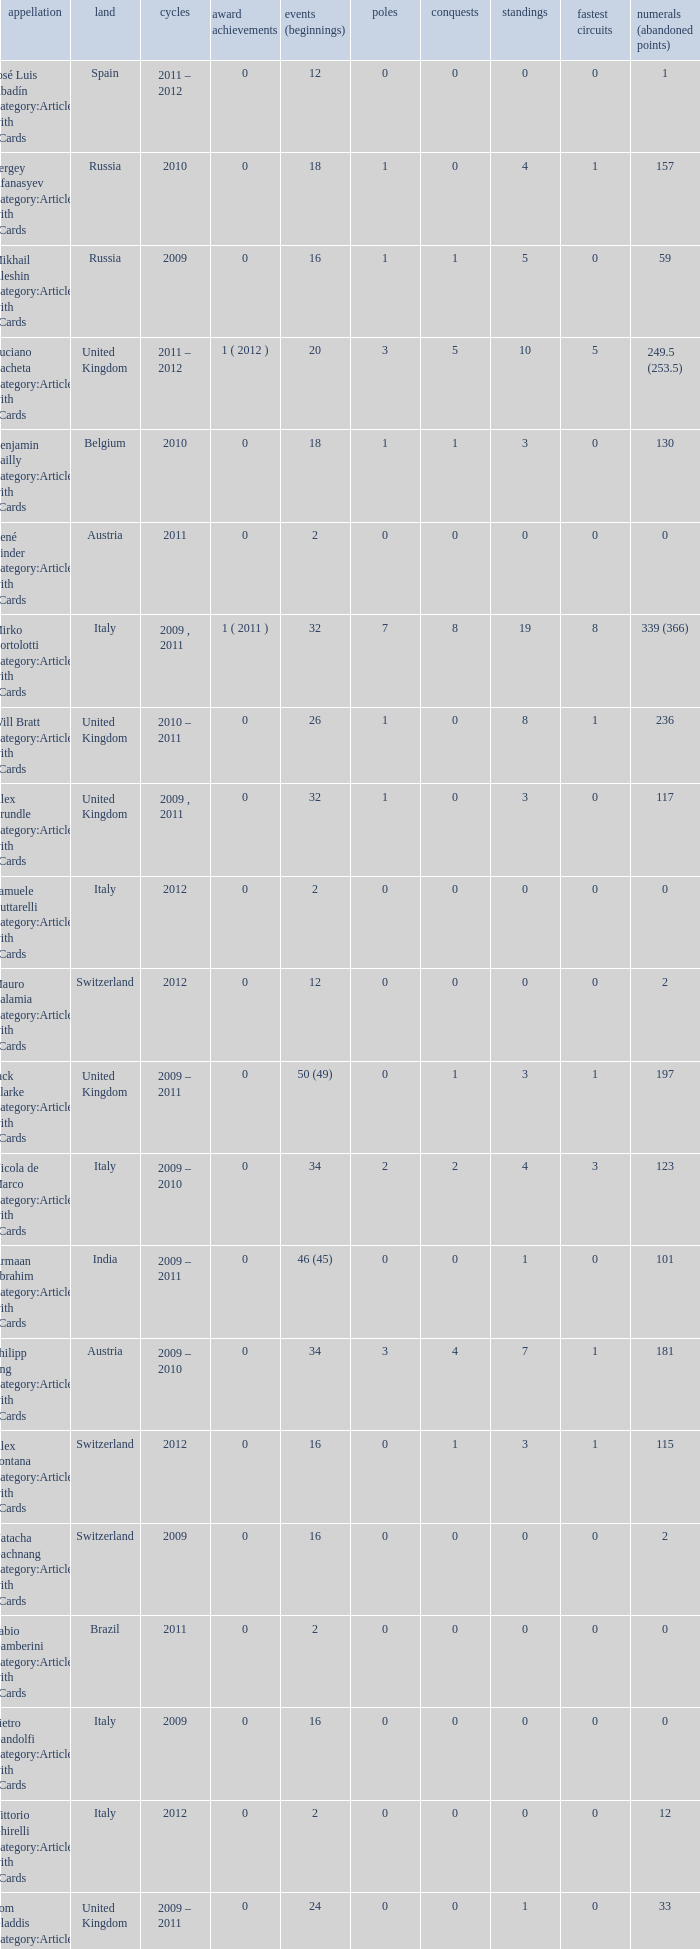What was the least amount of wins? 0.0. Could you parse the entire table as a dict? {'header': ['appellation', 'land', 'cycles', 'award achievements', 'events (beginnings)', 'poles', 'conquests', 'standings', 'fastest circuits', 'numerals (abandoned points)'], 'rows': [['José Luis Abadín Category:Articles with hCards', 'Spain', '2011 – 2012', '0', '12', '0', '0', '0', '0', '1'], ['Sergey Afanasyev Category:Articles with hCards', 'Russia', '2010', '0', '18', '1', '0', '4', '1', '157'], ['Mikhail Aleshin Category:Articles with hCards', 'Russia', '2009', '0', '16', '1', '1', '5', '0', '59'], ['Luciano Bacheta Category:Articles with hCards', 'United Kingdom', '2011 – 2012', '1 ( 2012 )', '20', '3', '5', '10', '5', '249.5 (253.5)'], ['Benjamin Bailly Category:Articles with hCards', 'Belgium', '2010', '0', '18', '1', '1', '3', '0', '130'], ['René Binder Category:Articles with hCards', 'Austria', '2011', '0', '2', '0', '0', '0', '0', '0'], ['Mirko Bortolotti Category:Articles with hCards', 'Italy', '2009 , 2011', '1 ( 2011 )', '32', '7', '8', '19', '8', '339 (366)'], ['Will Bratt Category:Articles with hCards', 'United Kingdom', '2010 – 2011', '0', '26', '1', '0', '8', '1', '236'], ['Alex Brundle Category:Articles with hCards', 'United Kingdom', '2009 , 2011', '0', '32', '1', '0', '3', '0', '117'], ['Samuele Buttarelli Category:Articles with hCards', 'Italy', '2012', '0', '2', '0', '0', '0', '0', '0'], ['Mauro Calamia Category:Articles with hCards', 'Switzerland', '2012', '0', '12', '0', '0', '0', '0', '2'], ['Jack Clarke Category:Articles with hCards', 'United Kingdom', '2009 – 2011', '0', '50 (49)', '0', '1', '3', '1', '197'], ['Nicola de Marco Category:Articles with hCards', 'Italy', '2009 – 2010', '0', '34', '2', '2', '4', '3', '123'], ['Armaan Ebrahim Category:Articles with hCards', 'India', '2009 – 2011', '0', '46 (45)', '0', '0', '1', '0', '101'], ['Philipp Eng Category:Articles with hCards', 'Austria', '2009 – 2010', '0', '34', '3', '4', '7', '1', '181'], ['Alex Fontana Category:Articles with hCards', 'Switzerland', '2012', '0', '16', '0', '1', '3', '1', '115'], ['Natacha Gachnang Category:Articles with hCards', 'Switzerland', '2009', '0', '16', '0', '0', '0', '0', '2'], ['Fabio Gamberini Category:Articles with hCards', 'Brazil', '2011', '0', '2', '0', '0', '0', '0', '0'], ['Pietro Gandolfi Category:Articles with hCards', 'Italy', '2009', '0', '16', '0', '0', '0', '0', '0'], ['Vittorio Ghirelli Category:Articles with hCards', 'Italy', '2012', '0', '2', '0', '0', '0', '0', '12'], ['Tom Gladdis Category:Articles with hCards', 'United Kingdom', '2009 – 2011', '0', '24', '0', '0', '1', '0', '33'], ['Richard Gonda Category:Articles with hCards', 'Slovakia', '2012', '0', '2', '0', '0', '0', '0', '4'], ['Victor Guerin Category:Articles with hCards', 'Brazil', '2012', '0', '2', '0', '0', '0', '0', '2'], ['Ollie Hancock Category:Articles with hCards', 'United Kingdom', '2009', '0', '6', '0', '0', '0', '0', '0'], ['Tobias Hegewald Category:Articles with hCards', 'Germany', '2009 , 2011', '0', '32', '4', '2', '5', '3', '158'], ['Sebastian Hohenthal Category:Articles with hCards', 'Sweden', '2009', '0', '16', '0', '0', '0', '0', '7'], ['Jens Höing Category:Articles with hCards', 'Germany', '2009', '0', '16', '0', '0', '0', '0', '0'], ['Hector Hurst Category:Articles with hCards', 'United Kingdom', '2012', '0', '16', '0', '0', '0', '0', '27'], ['Carlos Iaconelli Category:Articles with hCards', 'Brazil', '2009', '0', '14', '0', '0', '1', '0', '21'], ['Axcil Jefferies Category:Articles with hCards', 'Zimbabwe', '2012', '0', '12 (11)', '0', '0', '0', '0', '17'], ['Johan Jokinen Category:Articles with hCards', 'Denmark', '2010', '0', '6', '0', '0', '1', '1', '21'], ['Julien Jousse Category:Articles with hCards', 'France', '2009', '0', '16', '1', '1', '4', '2', '49'], ['Henri Karjalainen Category:Articles with hCards', 'Finland', '2009', '0', '16', '0', '0', '0', '0', '7'], ['Kourosh Khani Category:Articles with hCards', 'Iran', '2012', '0', '8', '0', '0', '0', '0', '2'], ['Jordan King Category:Articles with hCards', 'United Kingdom', '2011', '0', '6', '0', '0', '0', '0', '17'], ['Natalia Kowalska Category:Articles with hCards', 'Poland', '2010 – 2011', '0', '20', '0', '0', '0', '0', '3'], ['Plamen Kralev Category:Articles with hCards', 'Bulgaria', '2010 – 2012', '0', '50 (49)', '0', '0', '0', '0', '6'], ['Ajith Kumar Category:Articles with hCards', 'India', '2010', '0', '6', '0', '0', '0', '0', '0'], ['Jon Lancaster Category:Articles with hCards', 'United Kingdom', '2011', '0', '2', '0', '0', '0', '0', '14'], ['Benjamin Lariche Category:Articles with hCards', 'France', '2010 – 2011', '0', '34', '0', '0', '0', '0', '48'], ['Mikkel Mac Category:Articles with hCards', 'Denmark', '2011', '0', '16', '0', '0', '0', '0', '23'], ['Mihai Marinescu Category:Articles with hCards', 'Romania', '2010 – 2012', '0', '50', '4', '3', '8', '4', '299'], ['Daniel McKenzie Category:Articles with hCards', 'United Kingdom', '2012', '0', '16', '0', '0', '2', '0', '95'], ['Kevin Mirocha Category:Articles with hCards', 'Poland', '2012', '0', '16', '1', '1', '6', '0', '159.5'], ['Miki Monrás Category:Articles with hCards', 'Spain', '2011', '0', '16', '1', '1', '4', '1', '153'], ['Jason Moore Category:Articles with hCards', 'United Kingdom', '2009', '0', '16 (15)', '0', '0', '0', '0', '3'], ['Sung-Hak Mun Category:Articles with hCards', 'South Korea', '2011', '0', '16 (15)', '0', '0', '0', '0', '0'], ['Jolyon Palmer Category:Articles with hCards', 'United Kingdom', '2009 – 2010', '0', '34 (36)', '5', '5', '10', '3', '245'], ['Miloš Pavlović Category:Articles with hCards', 'Serbia', '2009', '0', '16', '0', '0', '2', '1', '29'], ['Ramón Piñeiro Category:Articles with hCards', 'Spain', '2010 – 2011', '0', '18', '2', '3', '7', '2', '186'], ['Markus Pommer Category:Articles with hCards', 'Germany', '2012', '0', '16', '4', '3', '5', '2', '169'], ['Edoardo Piscopo Category:Articles with hCards', 'Italy', '2009', '0', '14', '0', '0', '0', '0', '19'], ['Paul Rees Category:Articles with hCards', 'United Kingdom', '2010', '0', '8', '0', '0', '0', '0', '18'], ['Ivan Samarin Category:Articles with hCards', 'Russia', '2010', '0', '18', '0', '0', '0', '0', '64'], ['Germán Sánchez Category:Articles with hCards', 'Spain', '2009', '0', '16 (14)', '0', '0', '0', '0', '2'], ['Harald Schlegelmilch Category:Articles with hCards', 'Latvia', '2012', '0', '2', '0', '0', '0', '0', '12'], ['Max Snegirev Category:Articles with hCards', 'Russia', '2011 – 2012', '0', '28', '0', '0', '0', '0', '20'], ['Kelvin Snoeks Category:Articles with hCards', 'Netherlands', '2010 – 2011', '0', '32', '0', '0', '1', '0', '88'], ['Andy Soucek Category:Articles with hCards', 'Spain', '2009', '1 ( 2009 )', '16', '2', '7', '11', '3', '115'], ['Dean Stoneman Category:Articles with hCards', 'United Kingdom', '2010', '1 ( 2010 )', '18', '6', '6', '13', '6', '284'], ['Thiemo Storz Category:Articles with hCards', 'Germany', '2011', '0', '16', '0', '0', '0', '0', '19'], ['Parthiva Sureshwaren Category:Articles with hCards', 'India', '2010 – 2012', '0', '32 (31)', '0', '0', '0', '0', '1'], ['Henry Surtees Category:Articles with hCards', 'United Kingdom', '2009', '0', '8', '1', '0', '1', '0', '8'], ['Ricardo Teixeira Category:Articles with hCards', 'Angola', '2010', '0', '18', '0', '0', '0', '0', '23'], ['Johannes Theobald Category:Articles with hCards', 'Germany', '2010 – 2011', '0', '14', '0', '0', '0', '0', '1'], ['Julian Theobald Category:Articles with hCards', 'Germany', '2010 – 2011', '0', '18', '0', '0', '0', '0', '8'], ['Mathéo Tuscher Category:Articles with hCards', 'Switzerland', '2012', '0', '16', '4', '2', '9', '1', '210'], ['Tristan Vautier Category:Articles with hCards', 'France', '2009', '0', '2', '0', '0', '1', '0', '9'], ['Kazim Vasiliauskas Category:Articles with hCards', 'Lithuania', '2009 – 2010', '0', '34', '3', '2', '10', '4', '198'], ['Robert Wickens Category:Articles with hCards', 'Canada', '2009', '0', '16', '5', '2', '6', '3', '64'], ['Dino Zamparelli Category:Articles with hCards', 'United Kingdom', '2012', '0', '16', '0', '0', '2', '0', '106.5'], ['Christopher Zanella Category:Articles with hCards', 'Switzerland', '2011 – 2012', '0', '32', '3', '4', '14', '5', '385 (401)']]} 